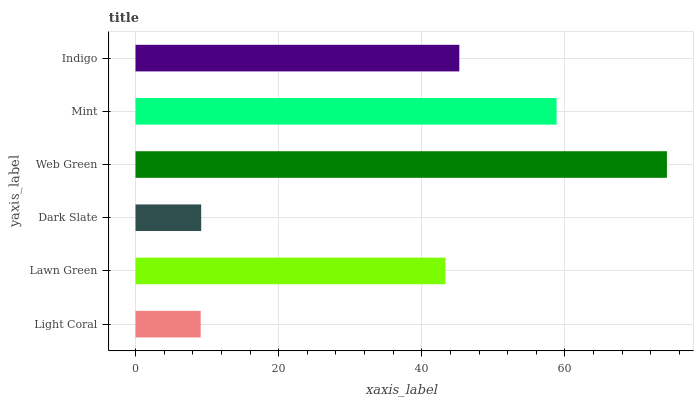Is Light Coral the minimum?
Answer yes or no. Yes. Is Web Green the maximum?
Answer yes or no. Yes. Is Lawn Green the minimum?
Answer yes or no. No. Is Lawn Green the maximum?
Answer yes or no. No. Is Lawn Green greater than Light Coral?
Answer yes or no. Yes. Is Light Coral less than Lawn Green?
Answer yes or no. Yes. Is Light Coral greater than Lawn Green?
Answer yes or no. No. Is Lawn Green less than Light Coral?
Answer yes or no. No. Is Indigo the high median?
Answer yes or no. Yes. Is Lawn Green the low median?
Answer yes or no. Yes. Is Mint the high median?
Answer yes or no. No. Is Dark Slate the low median?
Answer yes or no. No. 